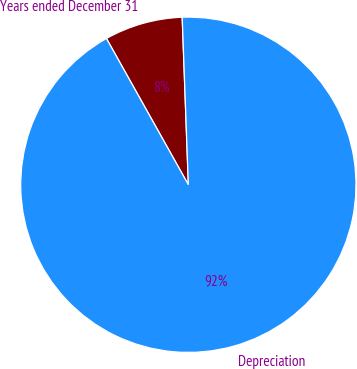Convert chart to OTSL. <chart><loc_0><loc_0><loc_500><loc_500><pie_chart><fcel>Years ended December 31<fcel>Depreciation<nl><fcel>7.54%<fcel>92.46%<nl></chart> 